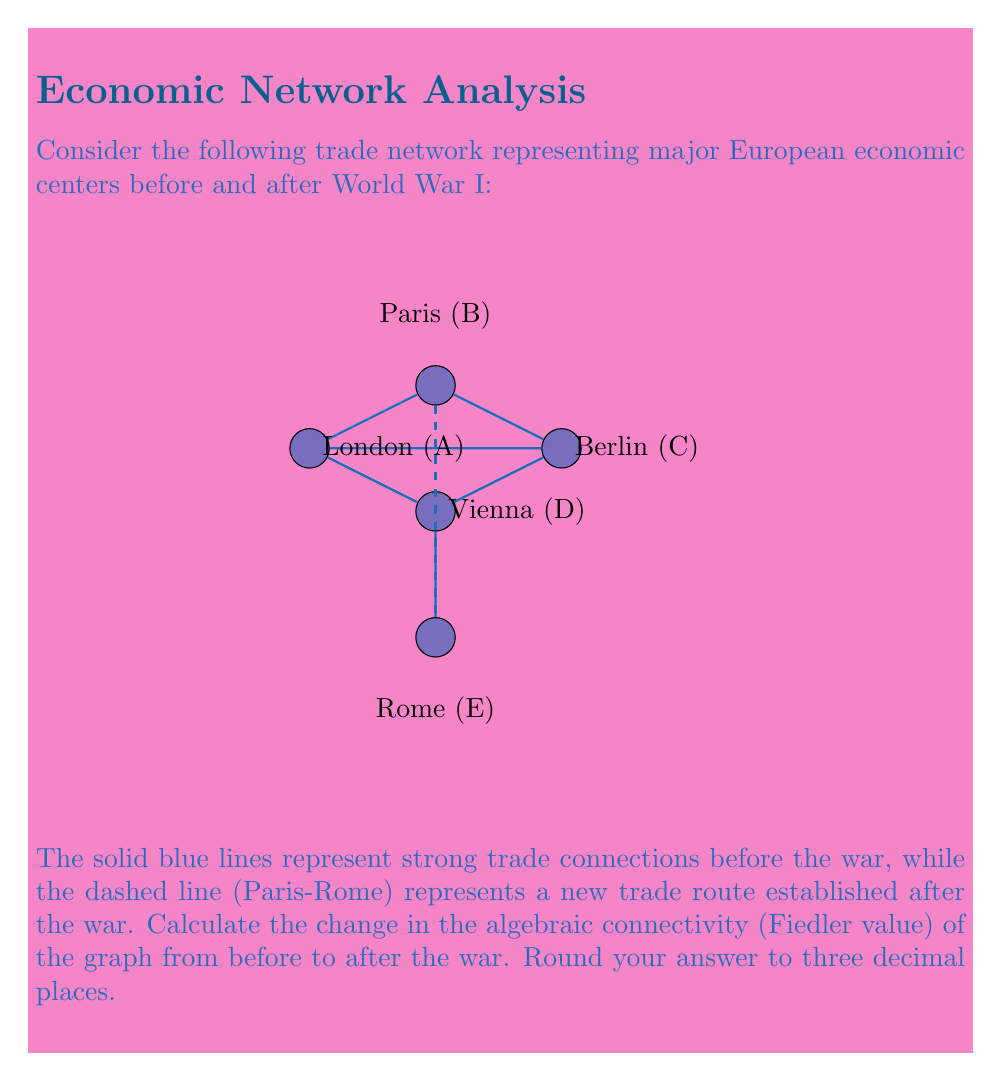Can you answer this question? To solve this problem, we need to follow these steps:

1) First, let's calculate the algebraic connectivity before the war:

   a) Construct the adjacency matrix A:
      $$A = \begin{bmatrix}
      0 & 1 & 1 & 1 & 0\\
      1 & 0 & 1 & 0 & 0\\
      1 & 1 & 0 & 1 & 0\\
      1 & 0 & 1 & 0 & 1\\
      0 & 0 & 0 & 1 & 0
      \end{bmatrix}$$

   b) Calculate the degree matrix D:
      $$D = \begin{bmatrix}
      3 & 0 & 0 & 0 & 0\\
      0 & 2 & 0 & 0 & 0\\
      0 & 0 & 3 & 0 & 0\\
      0 & 0 & 0 & 3 & 0\\
      0 & 0 & 0 & 0 & 1
      \end{bmatrix}$$

   c) Compute the Laplacian matrix L = D - A:
      $$L = \begin{bmatrix}
      3 & -1 & -1 & -1 & 0\\
      -1 & 2 & -1 & 0 & 0\\
      -1 & -1 & 3 & -1 & 0\\
      -1 & 0 & -1 & 3 & -1\\
      0 & 0 & 0 & -1 & 1
      \end{bmatrix}$$

   d) Find the eigenvalues of L. The second smallest eigenvalue is the algebraic connectivity.
      Using a computer algebra system, we get:
      Eigenvalues ≈ {0, 0.5188, 2.0000, 3.2087, 6.2725}
      
      Therefore, the algebraic connectivity before the war is approximately 0.5188.

2) Now, let's calculate the algebraic connectivity after the war:

   a) The new adjacency matrix A':
      $$A' = \begin{bmatrix}
      0 & 1 & 1 & 1 & 0\\
      1 & 0 & 1 & 0 & 1\\
      1 & 1 & 0 & 1 & 0\\
      1 & 0 & 1 & 0 & 1\\
      0 & 1 & 0 & 1 & 0
      \end{bmatrix}$$

   b) The new degree matrix D':
      $$D' = \begin{bmatrix}
      3 & 0 & 0 & 0 & 0\\
      0 & 3 & 0 & 0 & 0\\
      0 & 0 & 3 & 0 & 0\\
      0 & 0 & 0 & 3 & 0\\
      0 & 0 & 0 & 0 & 2
      \end{bmatrix}$$

   c) The new Laplacian matrix L' = D' - A':
      $$L' = \begin{bmatrix}
      3 & -1 & -1 & -1 & 0\\
      -1 & 3 & -1 & 0 & -1\\
      -1 & -1 & 3 & -1 & 0\\
      -1 & 0 & -1 & 3 & -1\\
      0 & -1 & 0 & -1 & 2
      \end{bmatrix}$$

   d) Find the eigenvalues of L'. Again, the second smallest eigenvalue is the algebraic connectivity.
      Using a computer algebra system, we get:
      Eigenvalues ≈ {0, 0.8299, 2.0000, 3.5850, 6.5851}
      
      Therefore, the algebraic connectivity after the war is approximately 0.8299.

3) Calculate the change in algebraic connectivity:
   Change = 0.8299 - 0.5188 ≈ 0.3111

Rounding to three decimal places, we get 0.311.
Answer: 0.311 